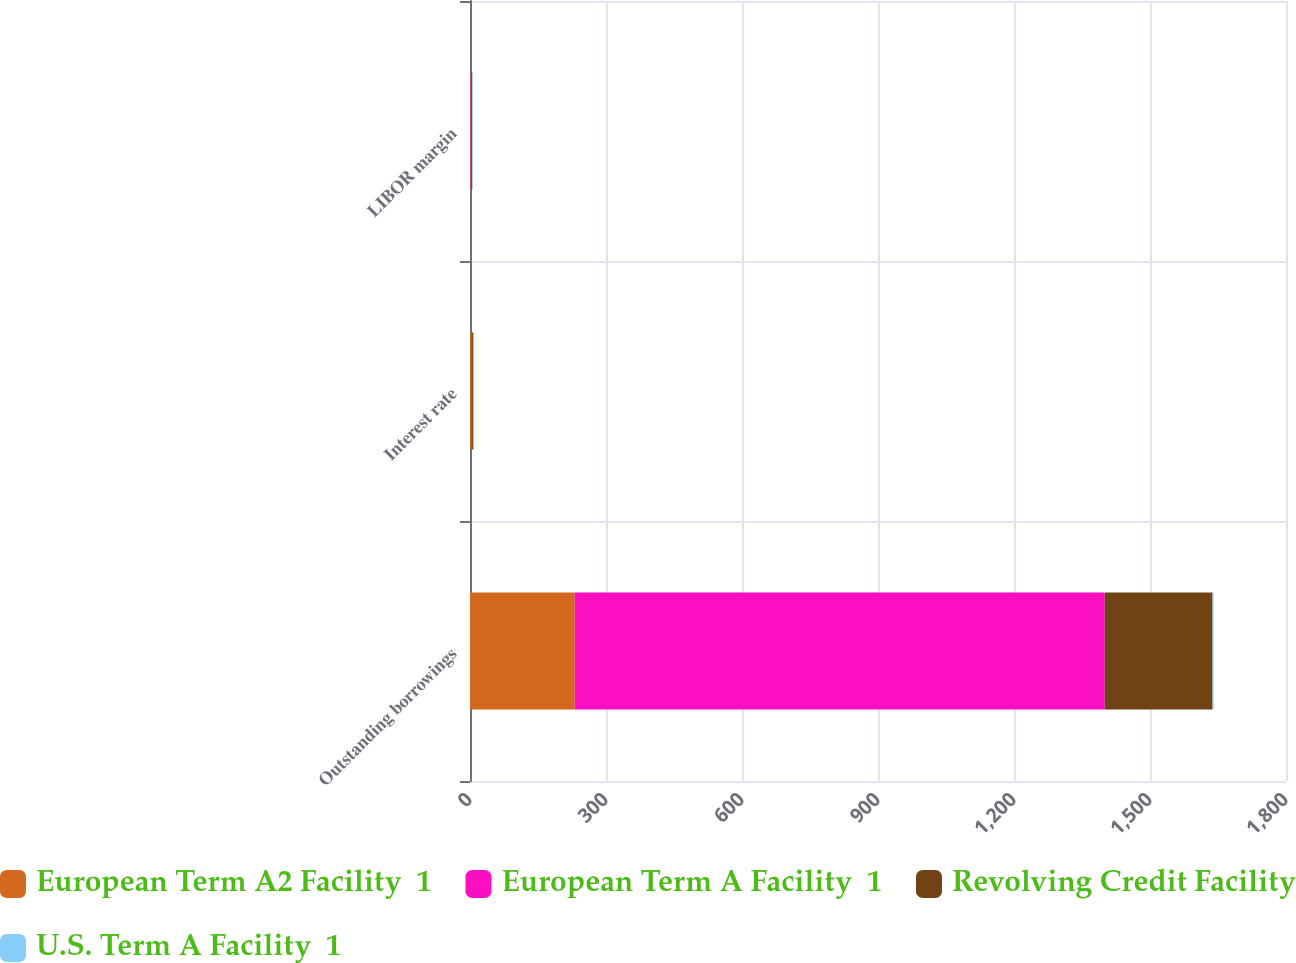<chart> <loc_0><loc_0><loc_500><loc_500><stacked_bar_chart><ecel><fcel>Outstanding borrowings<fcel>Interest rate<fcel>LIBOR margin<nl><fcel>European Term A2 Facility  1<fcel>231<fcel>2.3<fcel>1.5<nl><fcel>European Term A Facility  1<fcel>1169.1<fcel>2.3<fcel>1.5<nl><fcel>Revolving Credit Facility<fcel>237.9<fcel>2.5<fcel>1.75<nl><fcel>U.S. Term A Facility  1<fcel>2.3<fcel>2.3<fcel>1.5<nl></chart> 